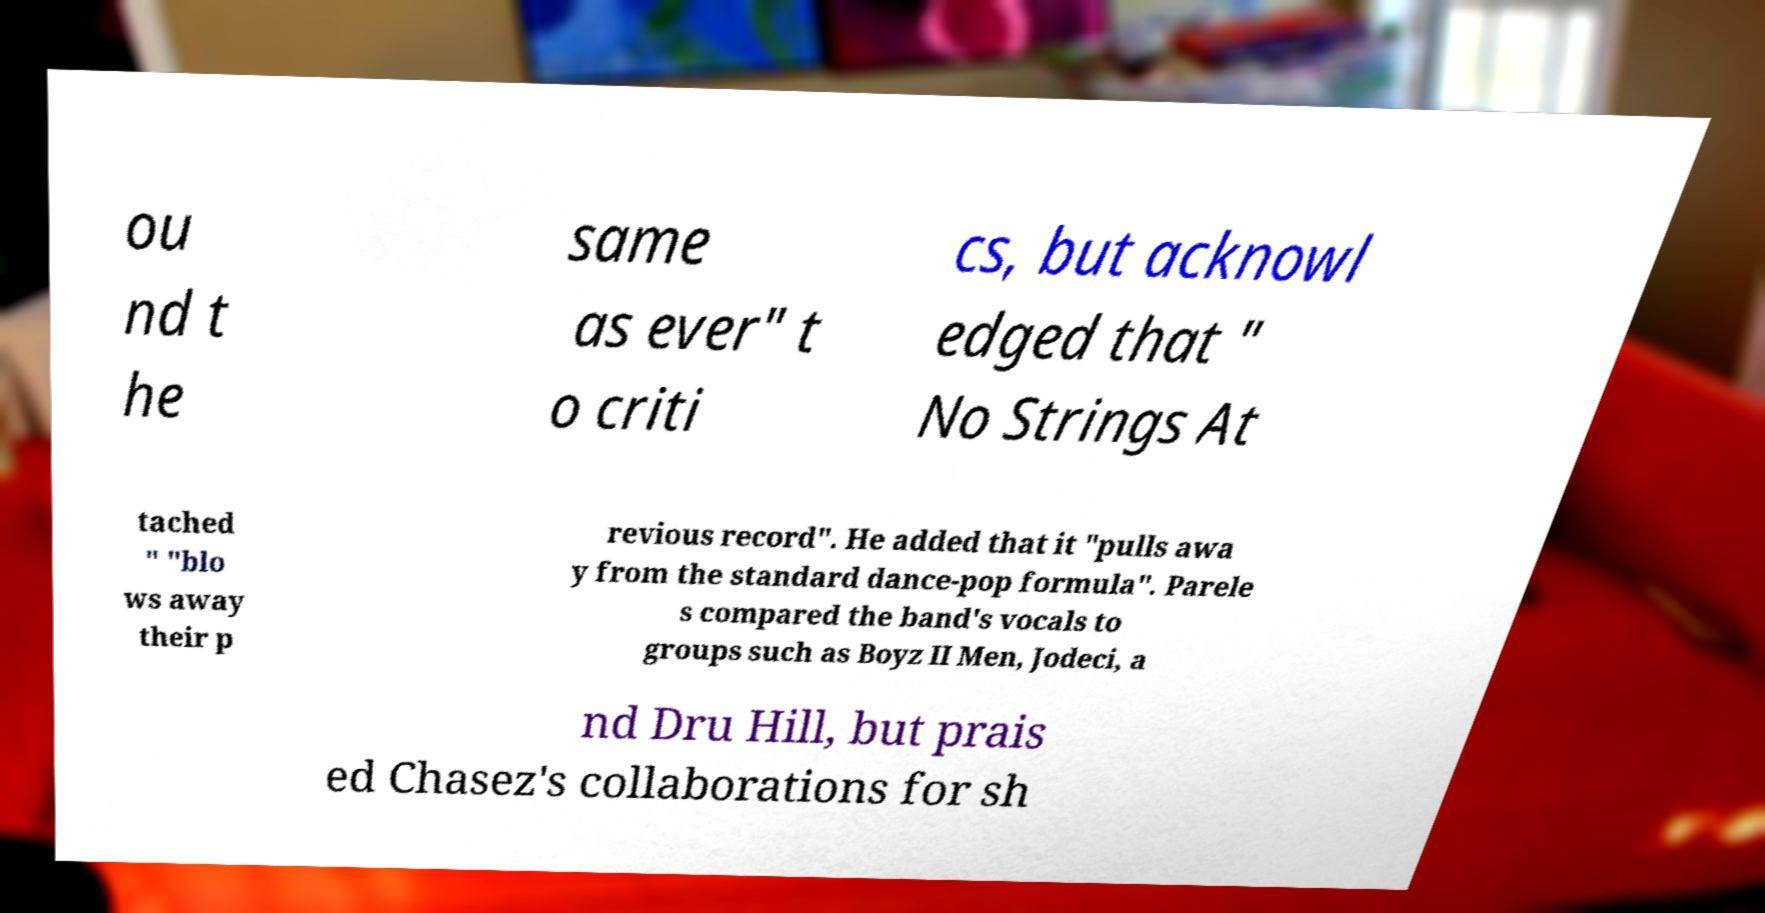What messages or text are displayed in this image? I need them in a readable, typed format. ou nd t he same as ever" t o criti cs, but acknowl edged that " No Strings At tached " "blo ws away their p revious record". He added that it "pulls awa y from the standard dance-pop formula". Parele s compared the band's vocals to groups such as Boyz II Men, Jodeci, a nd Dru Hill, but prais ed Chasez's collaborations for sh 